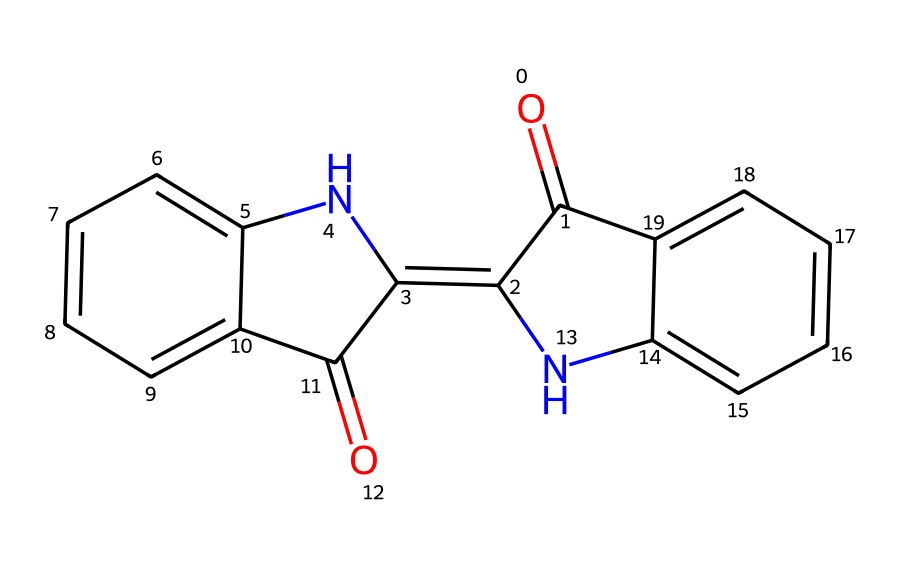What is the total number of carbon atoms in this chemical? To determine the total number of carbon atoms, count the carbon symbols present in the structure represented by the SMILES notation. There are 15 carbon atoms in total.
Answer: 15 How many nitrogen atoms are present in the chemical? By inspecting the structure through the SMILES notation, we can see two nitrogen symbols, indicating there are two nitrogen atoms present in the chemical.
Answer: 2 What type of chemical structure is represented by the SMILES? The chemical contains multiple rings and nitrogen atoms, suggesting it is a type of heterocyclic compound, likely an alkaloid or similar structure. A close inspection shows it is indeed an alkaloid, which is a class of cyclic organic compounds that often include nitrogen.
Answer: alkaloid Does this chemical contain any functional groups? The visible structure in the SMILES shows the presence of a carbonyl group (C=O) indicated by the notation O= and the adjacent positioning. This functional group contributes to the reactivity and properties of the compound.
Answer: carbonyl What is the inherent color property of this chemical? Given that this chemical is derived from natural sources for dyeing, it is known that compounds with multiple aromatic rings (seen in this structure) typically have vibrant colors, often yielding a deep hue used in dyes.
Answer: vibrant color Is this chemical soluble in water? Compounds such as those represented by this structure can often be polar due to the functional groups present. While specific solubility can vary, many natural dyes with nitrogen and carbonyl groups tend to have at least some degree of water solubility.
Answer: partially soluble 